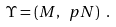Convert formula to latex. <formula><loc_0><loc_0><loc_500><loc_500>\Upsilon = ( M , \ p N ) \ .</formula> 